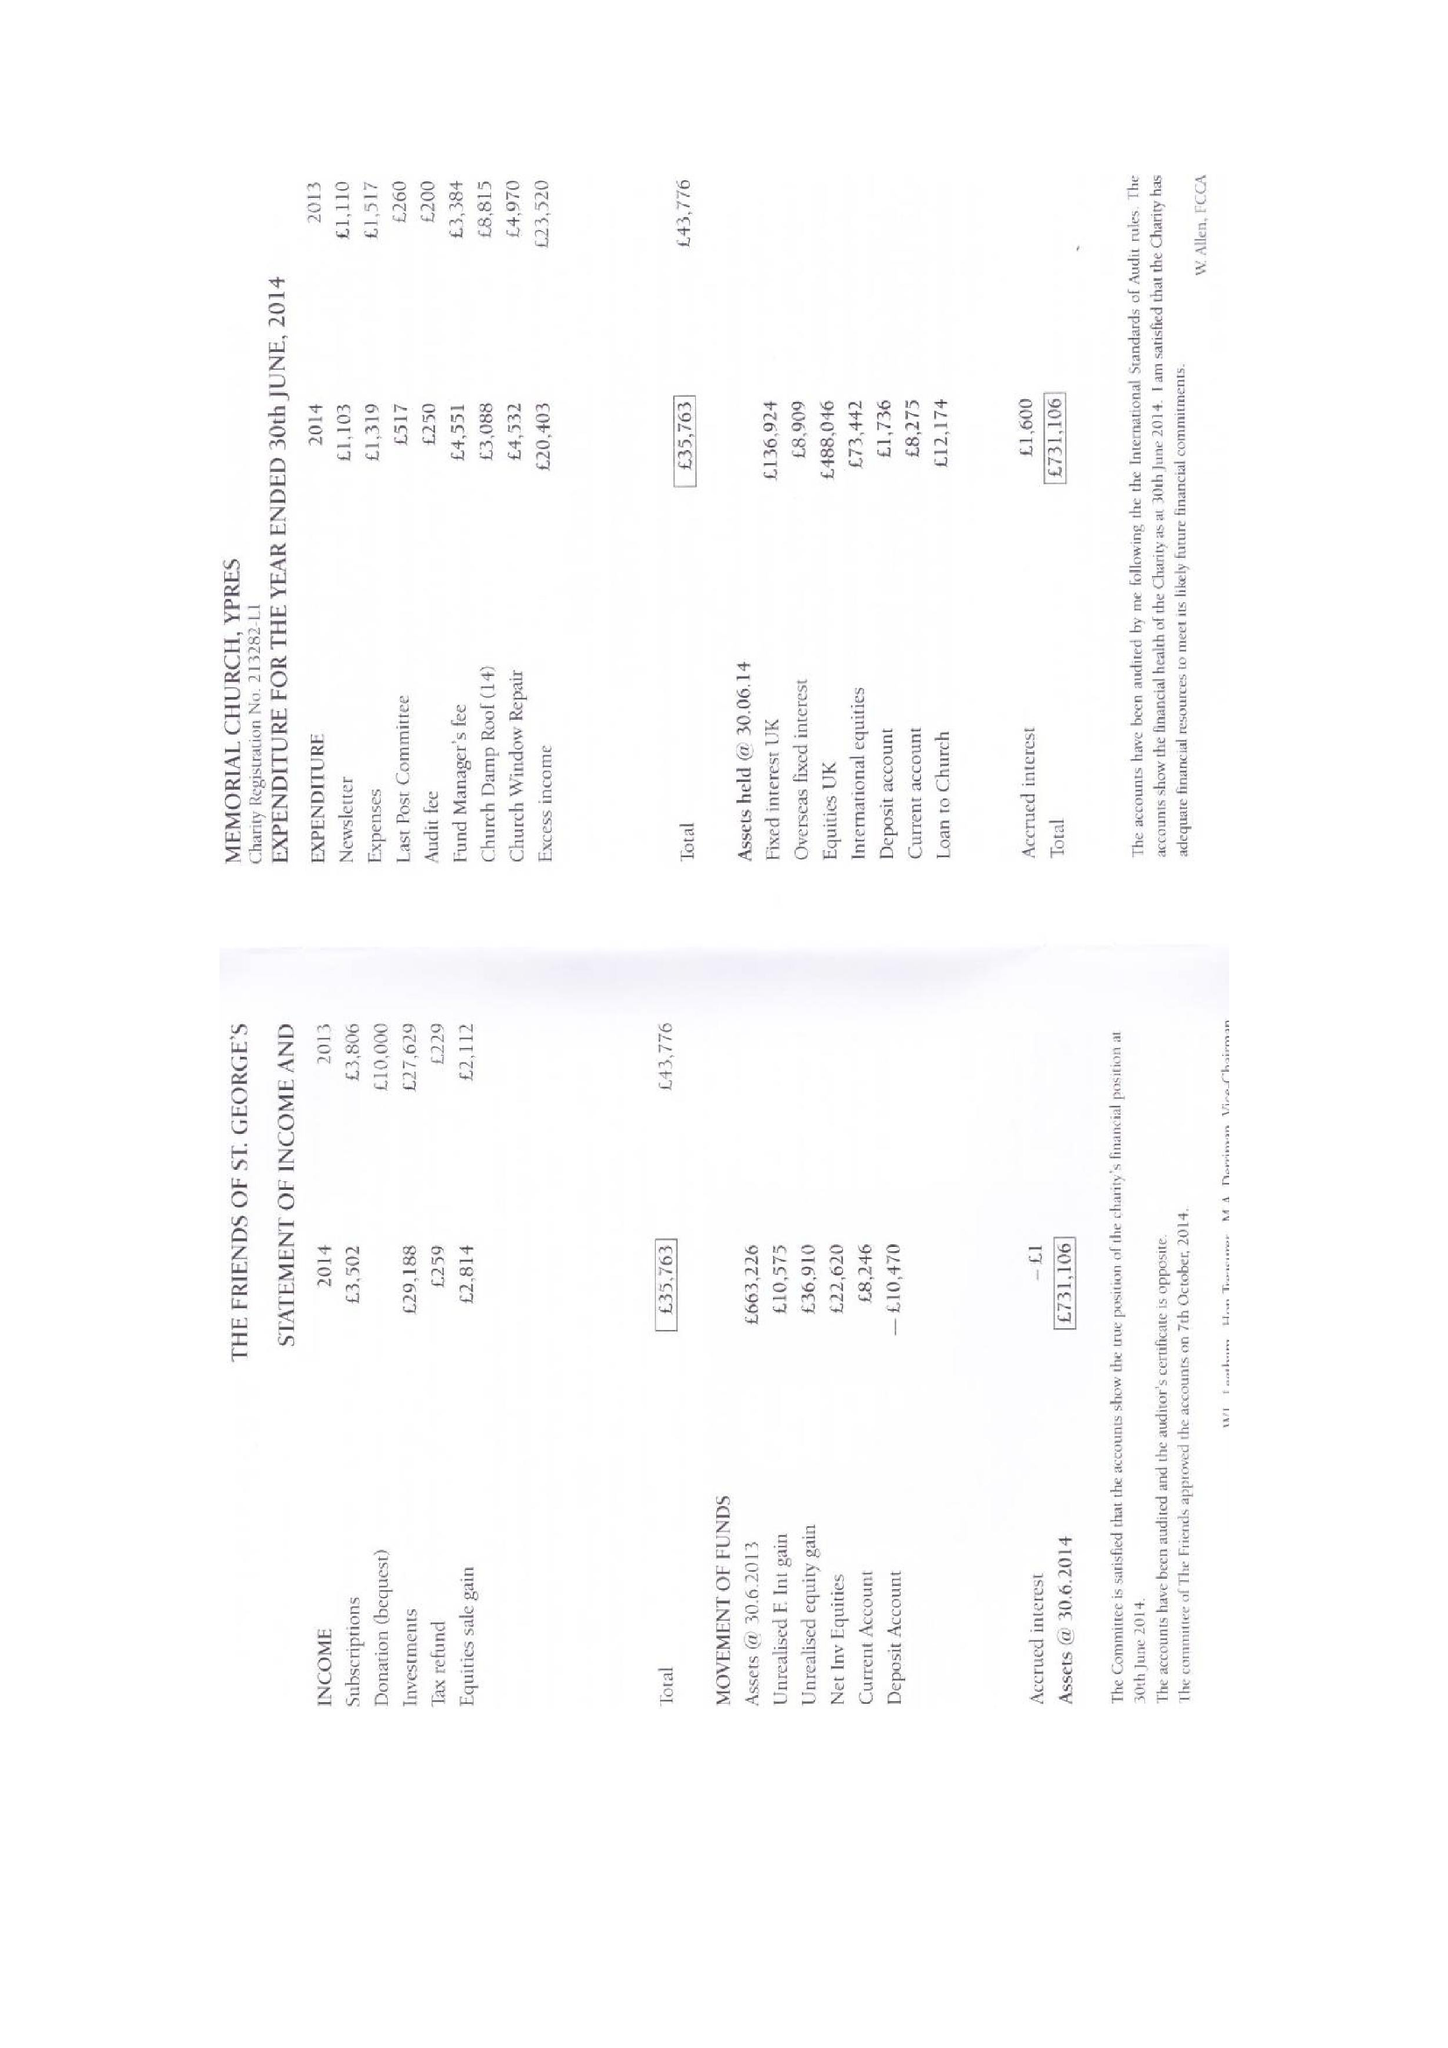What is the value for the address__postcode?
Answer the question using a single word or phrase. CT5 3BP 